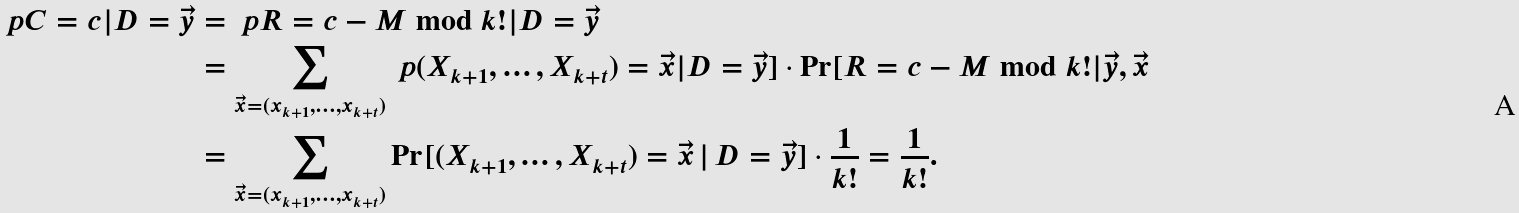Convert formula to latex. <formula><loc_0><loc_0><loc_500><loc_500>\ p { C = c | D = \vec { y } } & = \ p { R = c - M \bmod { k ! } | D = \vec { y } } \\ & = \sum _ { \vec { x } = ( x _ { k + 1 } , \dots , x _ { k + t } ) } \ p { ( X _ { k + 1 } , \dots , X _ { k + t } ) = \vec { x } | D = \vec { y } ] \cdot \Pr [ R = c - M \bmod { k ! } | \vec { y } , \vec { x } } \\ & = \sum _ { \vec { x } = ( x _ { k + 1 } , \dots , x _ { k + t } ) } \Pr [ ( X _ { k + 1 } , \dots , X _ { k + t } ) = \vec { x } \, | \, D = \vec { y } ] \cdot \frac { 1 } { k ! } = \frac { 1 } { k ! } .</formula> 